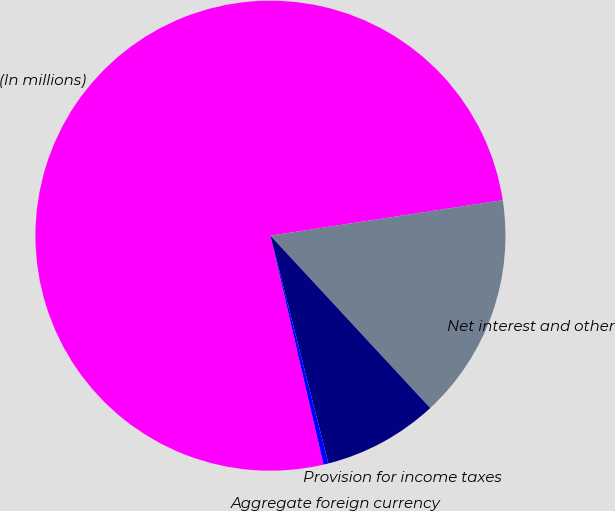Convert chart. <chart><loc_0><loc_0><loc_500><loc_500><pie_chart><fcel>(In millions)<fcel>Net interest and other<fcel>Provision for income taxes<fcel>Aggregate foreign currency<nl><fcel>76.22%<fcel>15.52%<fcel>7.93%<fcel>0.34%<nl></chart> 